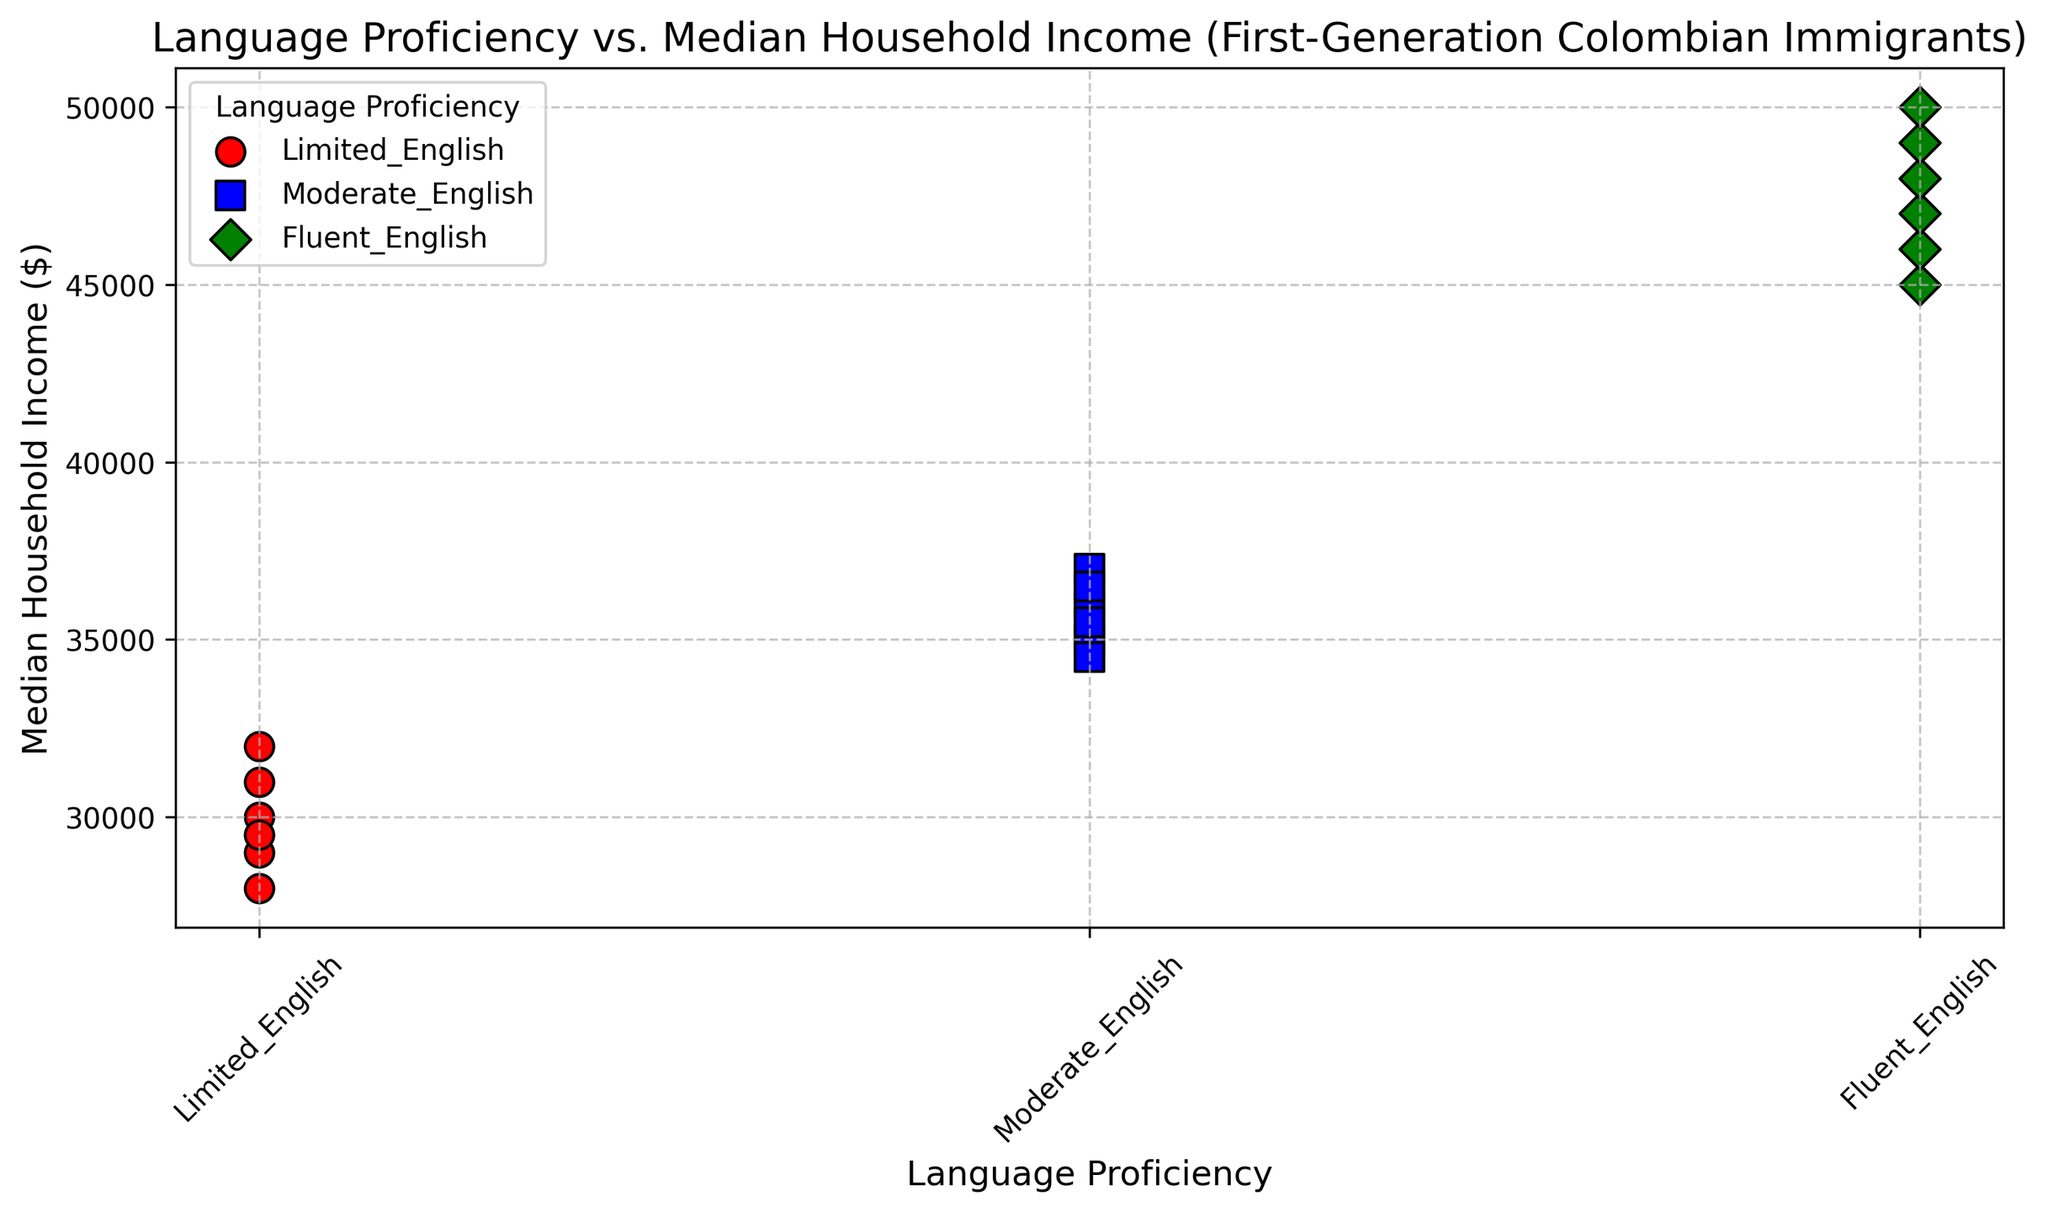What is the median household income for those proficient in fluent English? The scatter plot shows the median household income values for different language proficiency levels. For fluent English, the data points hover around 45000 to 50000 dollars. The middle value in this range directly represents the median income.
Answer: 47500 Which language proficiency group has the highest median household income? Looking at the scatter plot, the highest median household income values are associated with the fluent English proficiency group. This can be observed from the green diamond-shaped markers appearing at higher income levels than the other groups.
Answer: Fluent English What is the difference between the highest and lowest median household incomes for the limited English group? Within the limited English proficiency group, the highest median household income is $32000, and the lowest is $28000. The difference is found by subtracting the lowest value from the highest value: 32000 - 28000.
Answer: 4000 By how much does the median household income increase on average when moving from moderate English to fluent English? For moderate English, the median incomes are mostly between $34500 and $37000. For fluent English, they're between $45000 and $50000. The average increase can be calculated by taking the average of the ranges and finding the difference: (47500 - 35750).
Answer: 11750 What trend do you observe regarding language proficiency and median household income? The scatter plot indicates that as language proficiency improves from limited to fluent English, the median household income consistently increases. This upward trend is visually represented by the markers’ positions for each group: lower for limited, mid-level for moderate, and higher for fluent English.
Answer: Increases with proficiency Which color corresponds to the highest range of median household incomes? In the scatter plot, the green color markers represent the fluent English proficiency group. These markers appear in the highest median household income range, indicating that green corresponds to the highest income range.
Answer: Green Do any proficiency levels overlap in their median household income ranges? Observing the scatter plot, there is an overlap between the moderate and limited English proficiency levels, specifically around the $34500 to $37000 range. However, fluent English incomes are distinctly higher and do not overlap with the other groups.
Answer: Limited and Moderate overlap If a first-generation Colombian immigrant only has limited English proficiency, what’s the likely range of their median household income based on the figure? The scatter plot’s red markers represent limited English proficiency. These data points are clustered around the $28000 to $32000 range, providing the likely median household income for this group.
Answer: 28000 to 32000 By what percentage does the highest median household income for fluent English proficiency exceed that of limited English proficiency? The highest median household income for fluent English is $50000, while for limited English it is $32000. The percentage increase can be calculated as follows: ((50000 - 32000) / 32000) * 100.
Answer: 56.25% Which proficiency group has the smallest variability in median household income? The scatter plot shows that the data points for the moderate English group (blue squares) are more clustered together compared to the spread of the limited and fluent English groups. Hence, moderate English has the smallest income variability.
Answer: Moderate English 